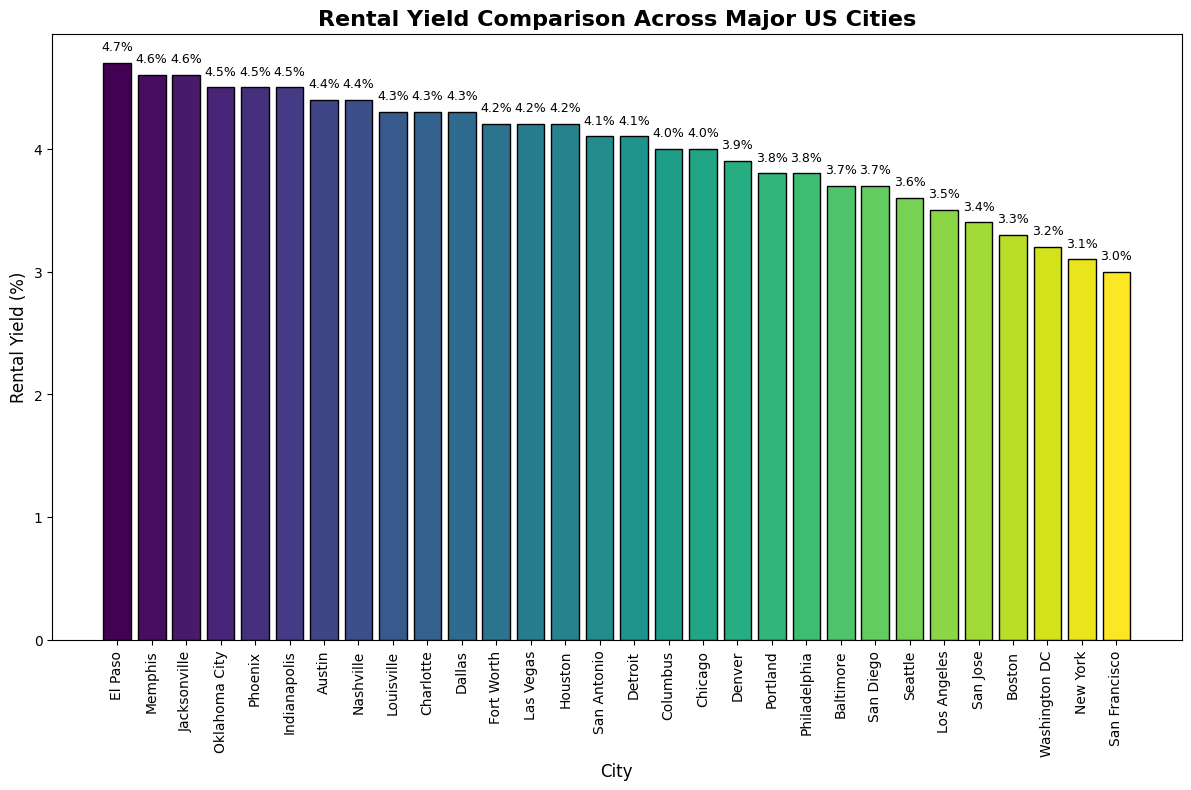Which city has the highest rental yield? Look for the tallest bar in the chart, which represents the highest rental yield. The city with this bar is El Paso.
Answer: El Paso What is the rental yield for New York? Identify the bar labeled 'New York' and read off the height of the bar to find the rental yield. The value is shown on top of the bar.
Answer: 3.1% Compare the rental yield between Dallas and Austin. Which city has a higher rental yield? Compare the heights of the bars for Dallas and Austin. The bar height indicates the rental yield, and Austin has a taller bar than Dallas.
Answer: Austin Which city has the lowest rental yield? Look for the shortest bar in the chart, which represents the lowest rental yield. The city with this bar is San Francisco.
Answer: San Francisco How many cities have a rental yield of 4.5% or higher? Count the bars that reach or exceed the 4.5% mark on the y-axis. The cities are Phoenix, Indianapolis, Jacksonville, Memphis, and El Paso, totaling five cities.
Answer: 5 What is the average rental yield across all cities shown in the chart? To find the average, sum up the rental yields of all cities and divide by the number of cities. The rental yields sum up to 115.2 and there are 30 cities. The average is 115.2 / 30.
Answer: 3.84% Which cities have a rental yield between 4.0% and 4.5%? Identify the bars whose heights fall between the 4.0% and 4.5% marks. The cities are Chicago, San Antonio, Dallas, Columbus, Charlotte, Austin, Oklahoma City, and Indianapolis.
Answer: Chicago, San Antonio, Dallas, Columbus, Charlotte, Austin, Oklahoma City, Indianapolis Which city has a rental yield closest to 4%? Find the bar closest to the 4% mark on the y-axis. Chicago has a rental yield exactly at 4%, making it the closest.
Answer: Chicago How does the rental yield in Washington DC compare to that in Boston? Compare the heights of the bars for Washington DC and Boston. Washington DC has a rental yield of 3.2%, while Boston has a rental yield of 3.3%. Boston is slightly higher.
Answer: Boston 